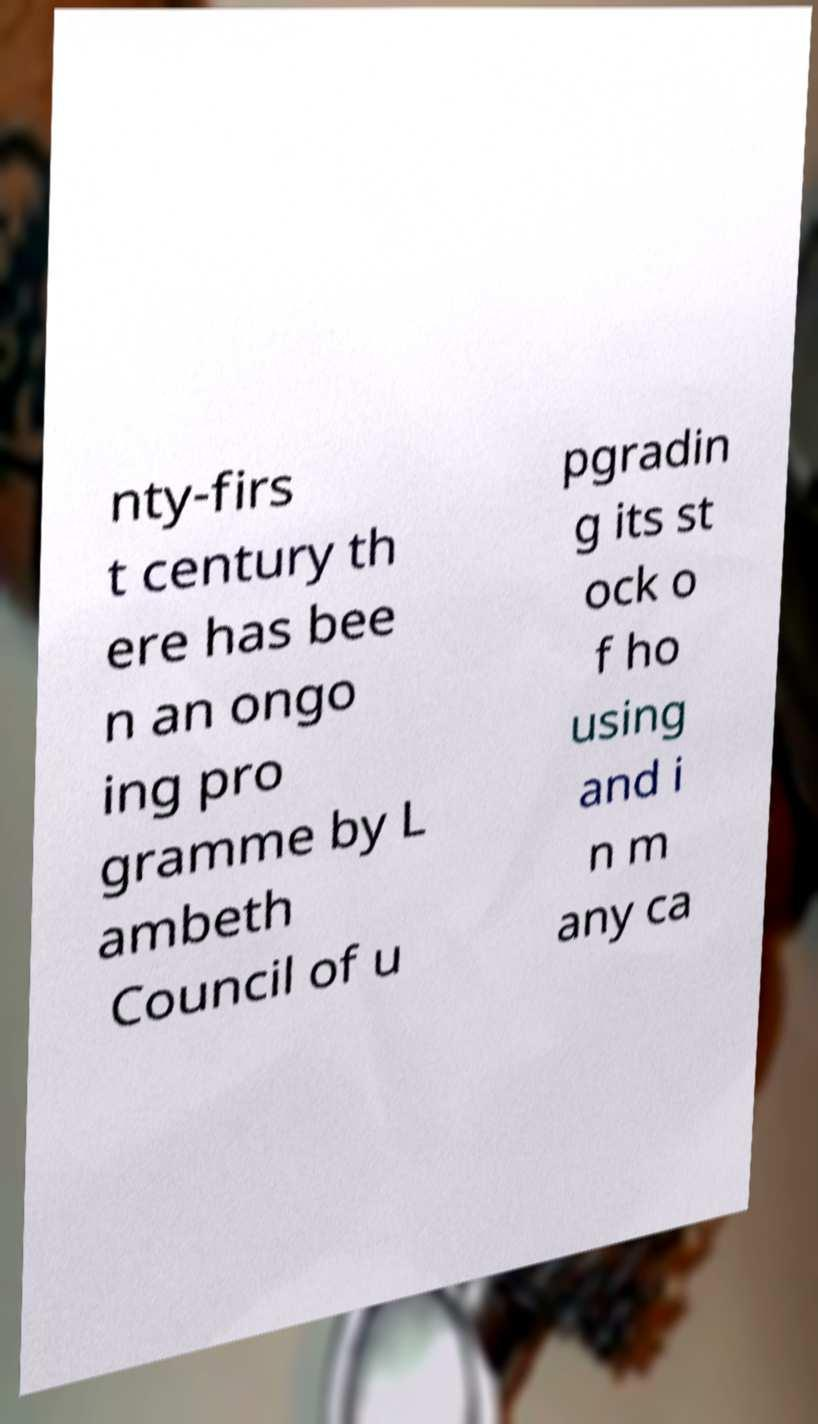Please read and relay the text visible in this image. What does it say? nty-firs t century th ere has bee n an ongo ing pro gramme by L ambeth Council of u pgradin g its st ock o f ho using and i n m any ca 